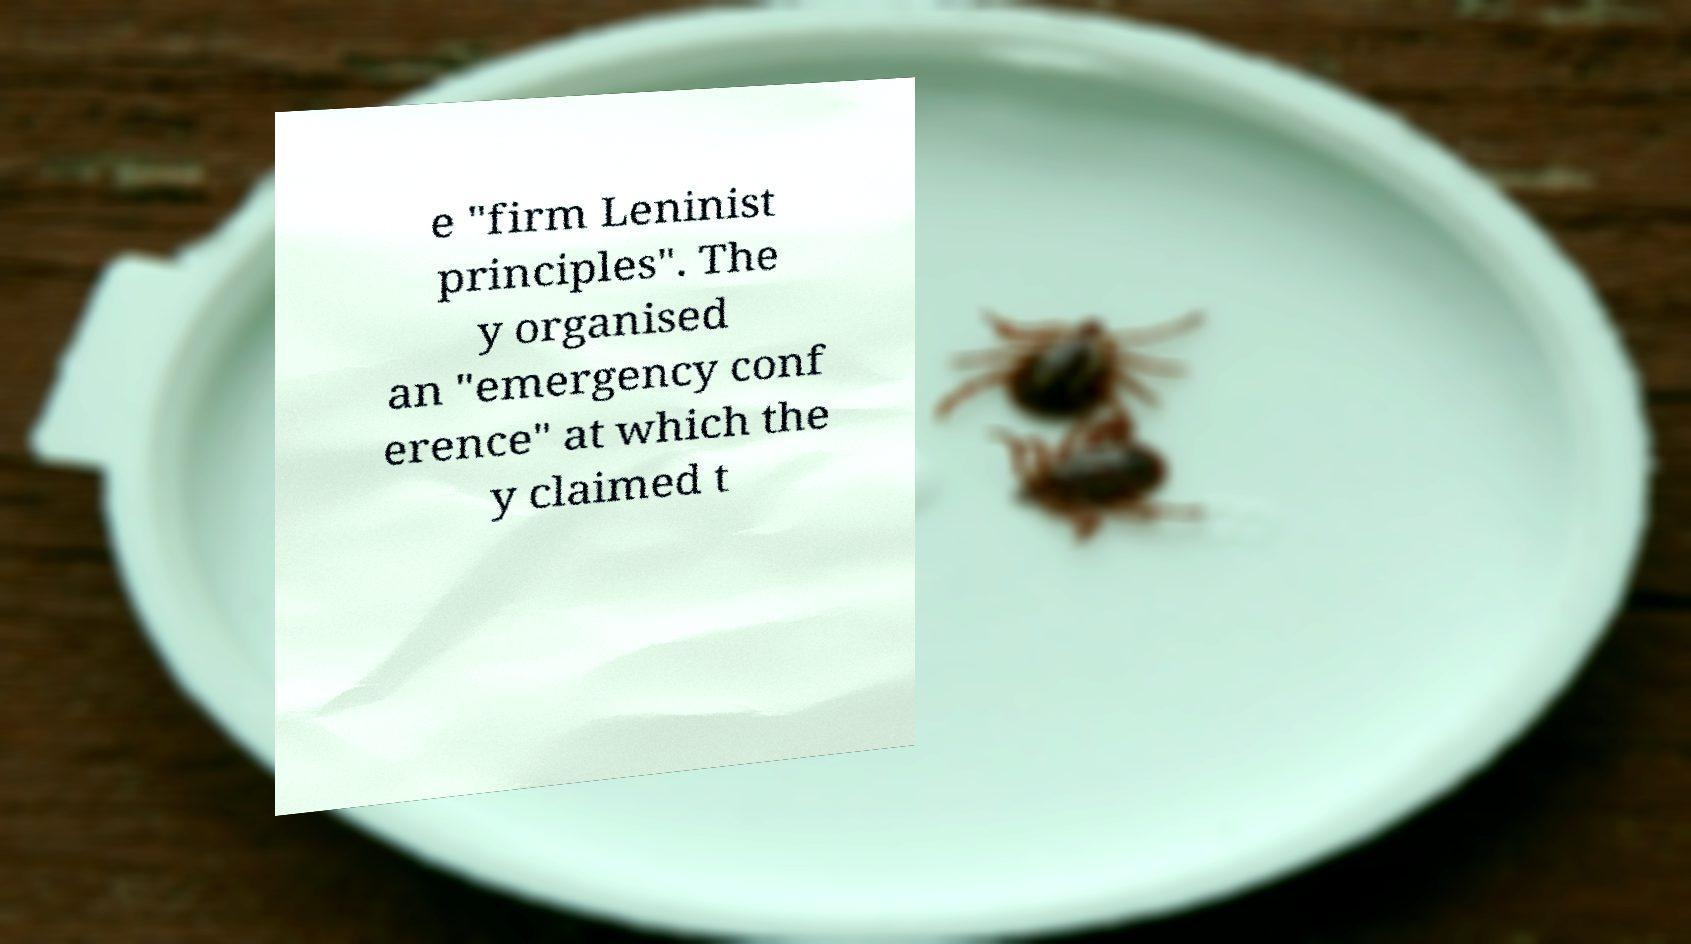There's text embedded in this image that I need extracted. Can you transcribe it verbatim? e "firm Leninist principles". The y organised an "emergency conf erence" at which the y claimed t 